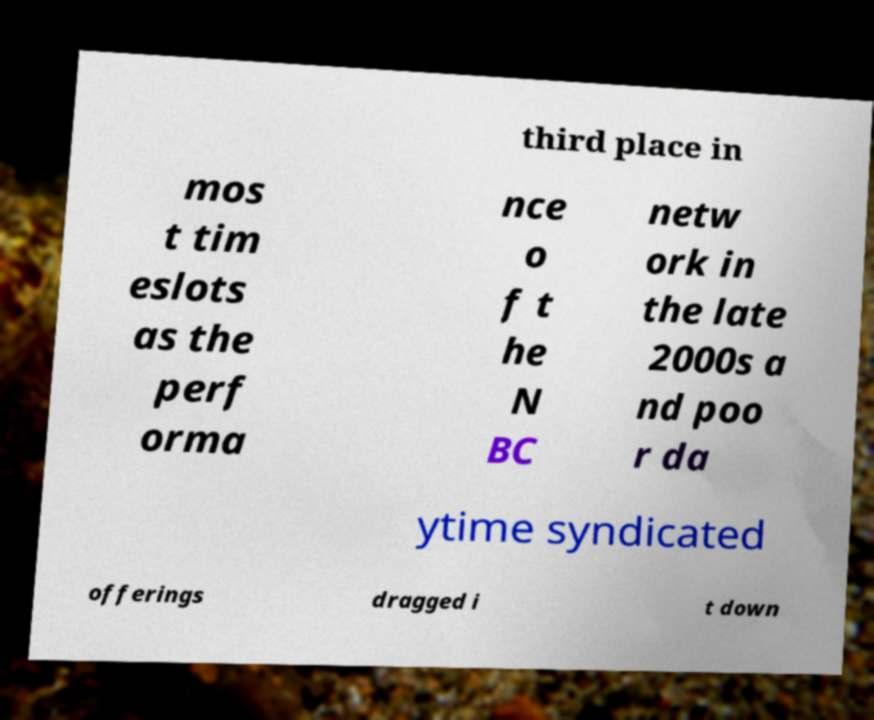I need the written content from this picture converted into text. Can you do that? third place in mos t tim eslots as the perf orma nce o f t he N BC netw ork in the late 2000s a nd poo r da ytime syndicated offerings dragged i t down 